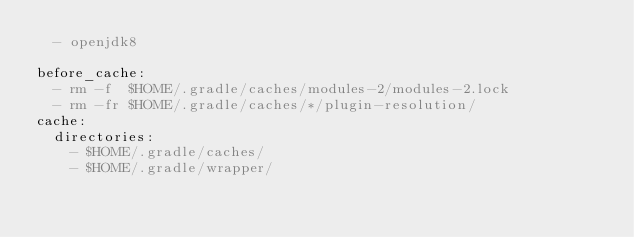Convert code to text. <code><loc_0><loc_0><loc_500><loc_500><_YAML_>  - openjdk8

before_cache:
  - rm -f  $HOME/.gradle/caches/modules-2/modules-2.lock
  - rm -fr $HOME/.gradle/caches/*/plugin-resolution/
cache:
  directories:
    - $HOME/.gradle/caches/
    - $HOME/.gradle/wrapper/</code> 